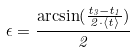Convert formula to latex. <formula><loc_0><loc_0><loc_500><loc_500>\epsilon = \frac { \arcsin ( \frac { t _ { 3 } - t _ { 1 } } { 2 \cdot \langle t \rangle } ) } { 2 }</formula> 